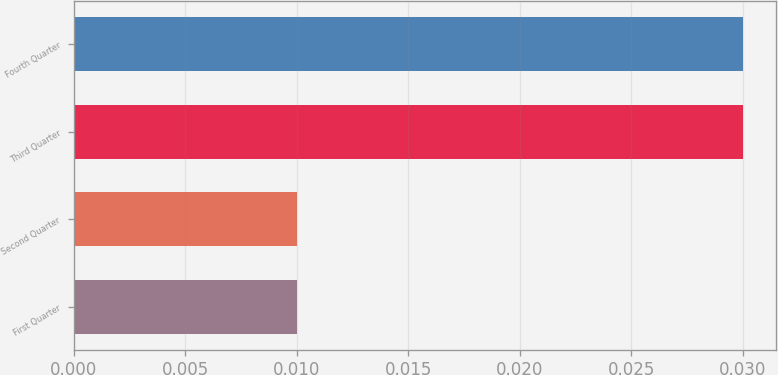Convert chart. <chart><loc_0><loc_0><loc_500><loc_500><bar_chart><fcel>First Quarter<fcel>Second Quarter<fcel>Third Quarter<fcel>Fourth Quarter<nl><fcel>0.01<fcel>0.01<fcel>0.03<fcel>0.03<nl></chart> 